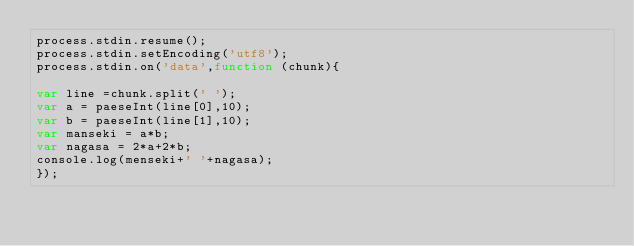Convert code to text. <code><loc_0><loc_0><loc_500><loc_500><_JavaScript_>process.stdin.resume();
process.stdin.setEncoding('utf8');
process.stdin.on('data',function (chunk){

var line =chunk.split(' ');
var a = paeseInt(line[0],10);
var b = paeseInt(line[1],10);
var manseki = a*b;
var nagasa = 2*a+2*b;
console.log(menseki+' '+nagasa);
});</code> 